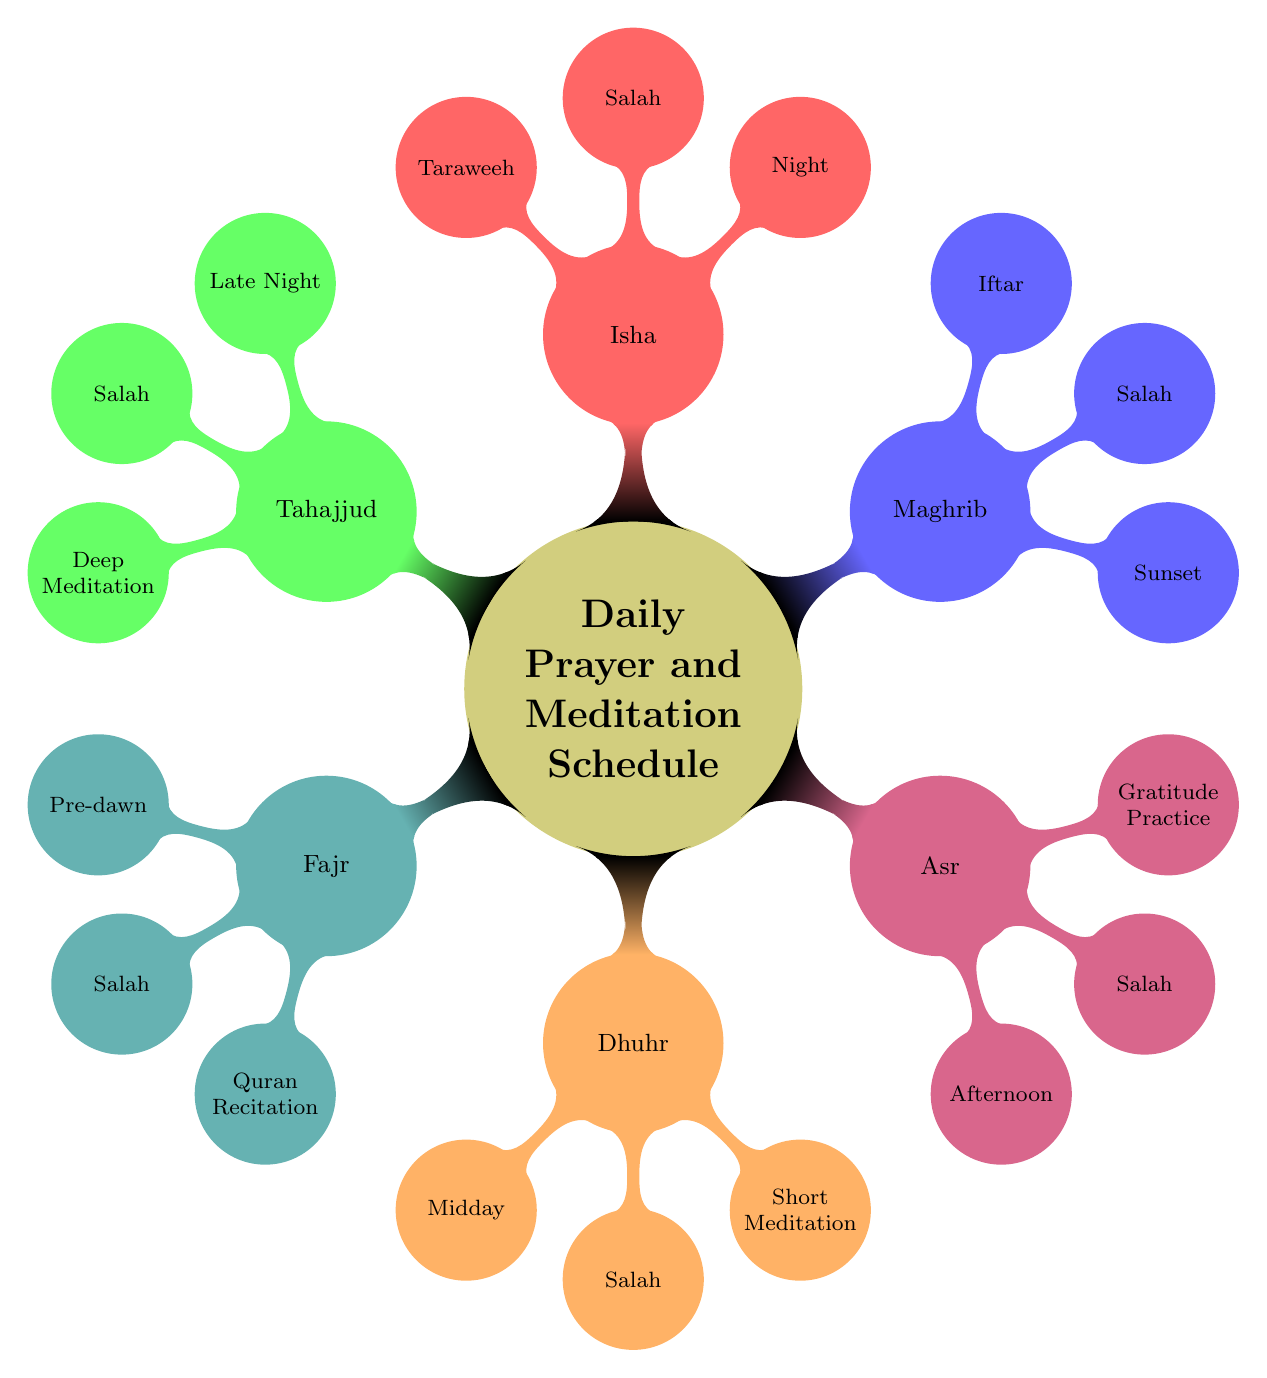What are the activities included in Fajr? The diagram lists three activities under the Fajr node: Salah, Quran Recitation, and Morning Dua.
Answer: Salah, Quran Recitation, Morning Dua What time is Asr prayer? According to the diagram, the time for Asr prayer is specified as "Afternoon."
Answer: Afternoon How many main prayer times are mentioned in the diagram? The diagram outlines six main prayer times: Fajr, Dhuhr, Asr, Maghrib, Isha, and Tahajjud. By counting these nodes, we find there are six.
Answer: 6 What is the main activity for Isha during Ramadan? For the Isha prayer, the specified activity during Ramadan is "Taraweeh."
Answer: Taraweeh Which prayer is associated with Iftar? The diagram indicates that Iftar is linked with the Maghrib prayer, as it is listed as an activity under that time.
Answer: Maghrib What activity is common to all prayer times? Each prayer time includes "Salah" as an activity, making it the common element across all times.
Answer: Salah What is the additional activity in Tahajjud? In the Tahajjud section of the diagram, "Deep Meditation" is noted as an additional activity along with Salah and Personal Supplication.
Answer: Deep Meditation Which prayer occurs at "Midday"? The diagram shows that Dhuhr is the prayer that occurs at "Midday."
Answer: Dhuhr What activity is suggested during the Dhuhr prayer aside from Salah? Besides Salah, the diagram mentions "Short Meditation" as another activity during Dhuhr.
Answer: Short Meditation 